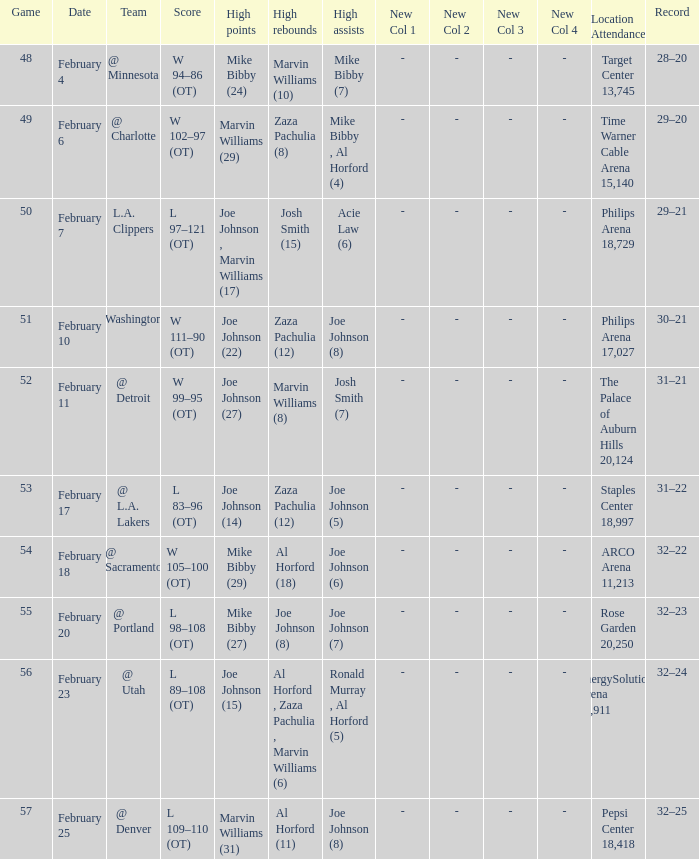How many high assists stats were maade on february 4 1.0. 